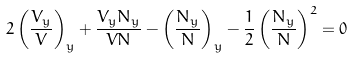<formula> <loc_0><loc_0><loc_500><loc_500>2 \left ( \frac { V _ { y } } { V } \right ) _ { y } + \frac { V _ { y } N _ { y } } { V N } - \left ( \frac { N _ { y } } { N } \right ) _ { y } - \frac { 1 } { 2 } \left ( \frac { N _ { y } } { N } \right ) ^ { 2 } = 0</formula> 